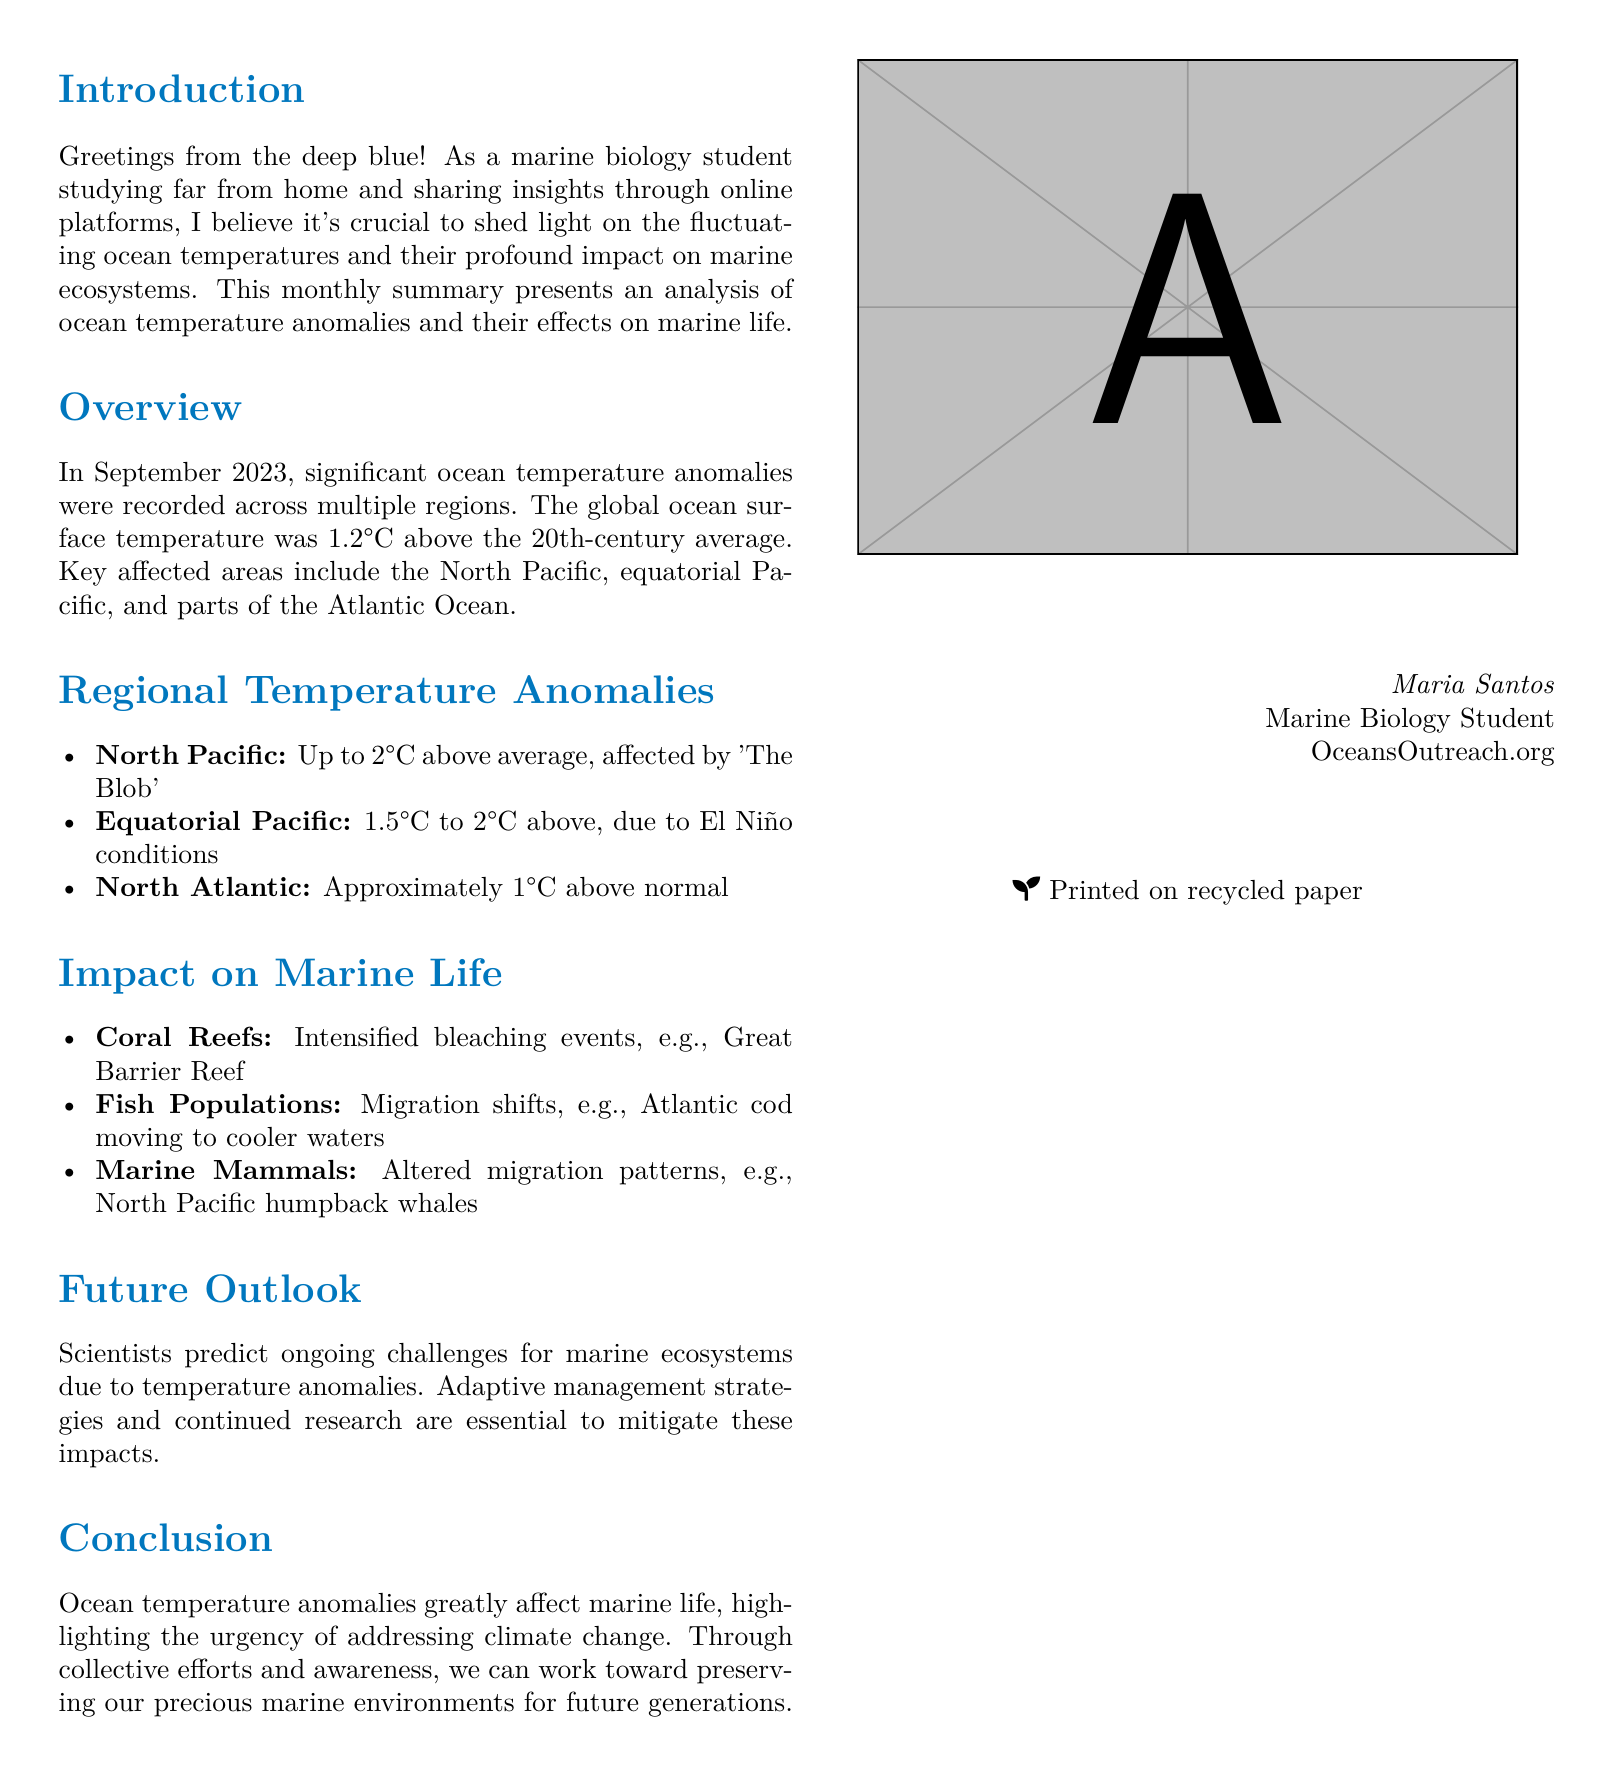What was the global ocean surface temperature anomaly in September 2023? The global ocean surface temperature anomaly is noted as being 1.2°C above the 20th-century average.
Answer: 1.2°C Which region recorded an anomaly of up to 2°C in September 2023? The North Pacific recorded an anomaly of up to 2°C above average, affected by 'The Blob.'
Answer: North Pacific What effect did the temperature anomalies have on coral reefs? The document states that there were intensified bleaching events, especially in the Great Barrier Reef.
Answer: Intensified bleaching events What fish population is mentioned as migrating to cooler waters? The document notes that Atlantic cod is migrating to cooler waters due to temperature anomalies.
Answer: Atlantic cod What climate phenomenon is associated with the 1.5°C to 2°C temperature anomaly in the equatorial Pacific? The temperature anomalies in the equatorial Pacific are linked to El Niño conditions.
Answer: El Niño What is the primary focus of the future outlook section? The future outlook discusses ongoing challenges for marine ecosystems due to temperature anomalies and the need for adaptive management.
Answer: Ongoing challenges for marine ecosystems Who is the author of the document? The author's name is provided in the conclusion section of the document.
Answer: Maria Santos What is the overarching theme addressed in the conclusion? The conclusion addresses the urgency of addressing climate change in relation to ocean temperature anomalies and marine life.
Answer: Urgency of addressing climate change 